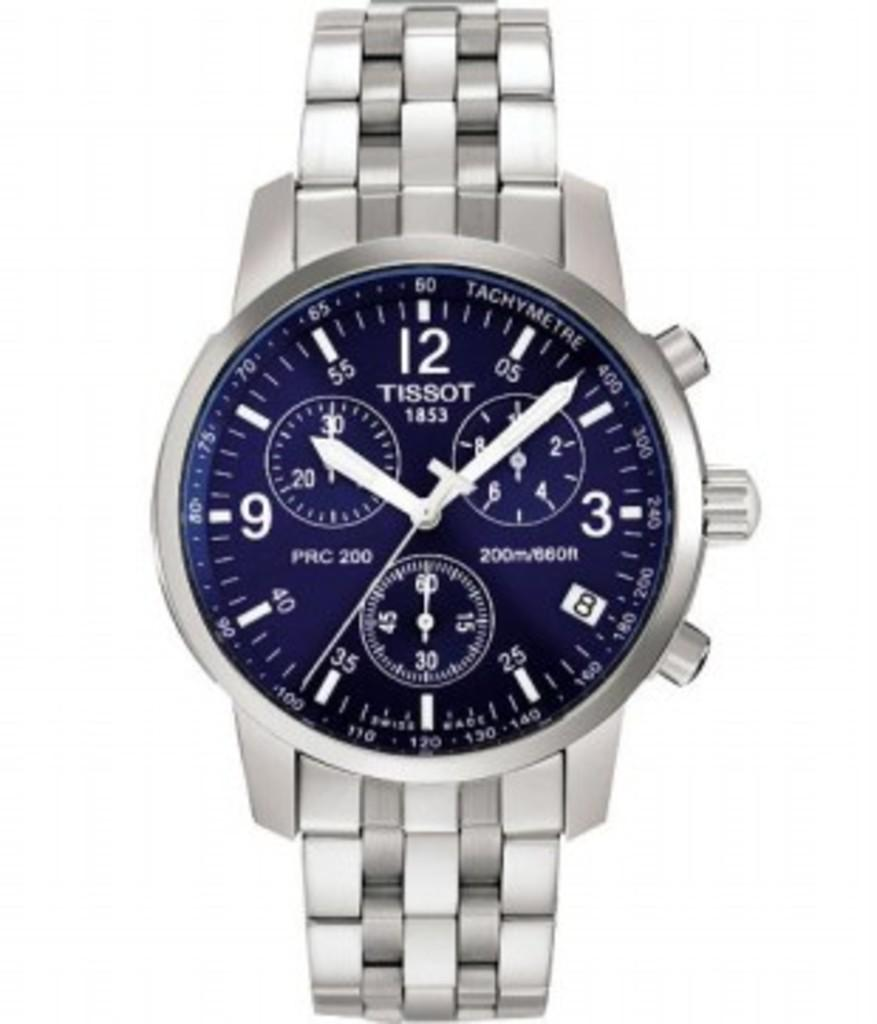<image>
Share a concise interpretation of the image provided. A silver TISSOT watch on a white background 